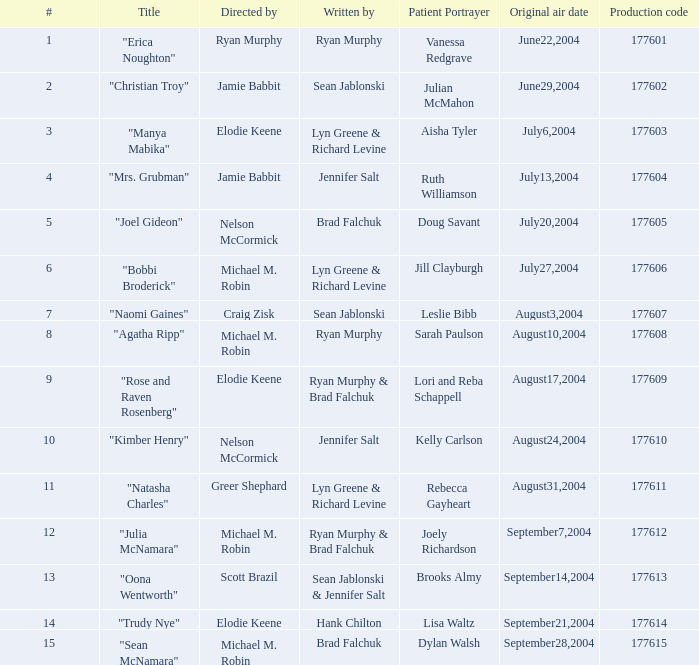Who penned the 28th episode? Brad Falchuk. 